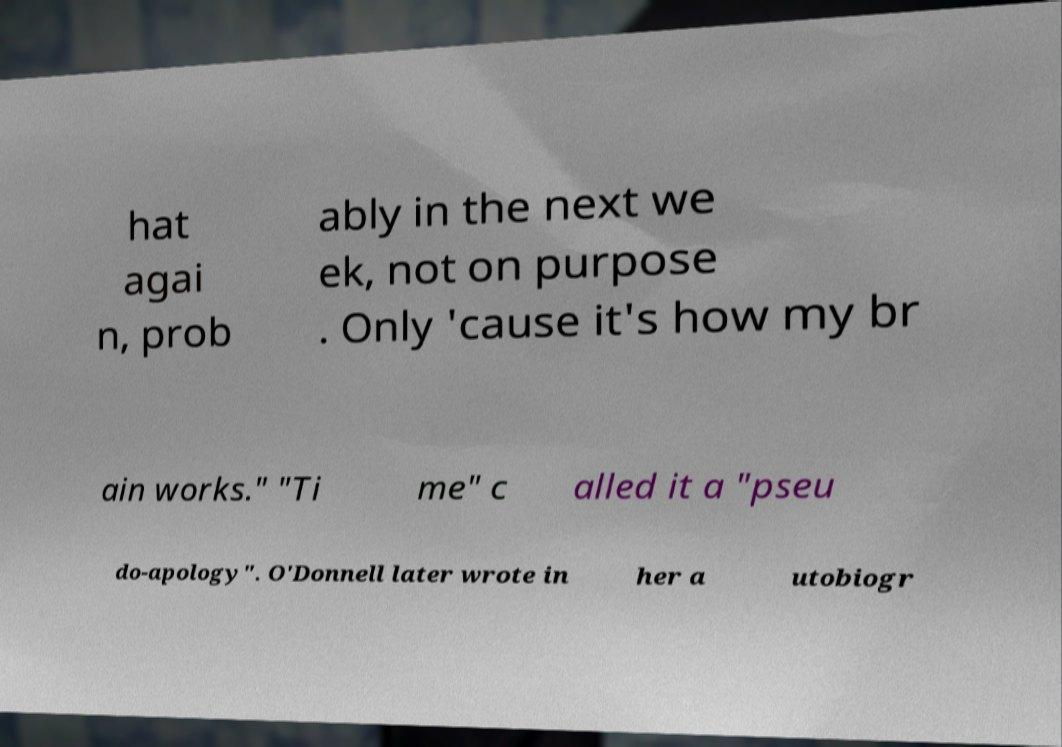Could you extract and type out the text from this image? hat agai n, prob ably in the next we ek, not on purpose . Only 'cause it's how my br ain works." "Ti me" c alled it a "pseu do-apology". O'Donnell later wrote in her a utobiogr 